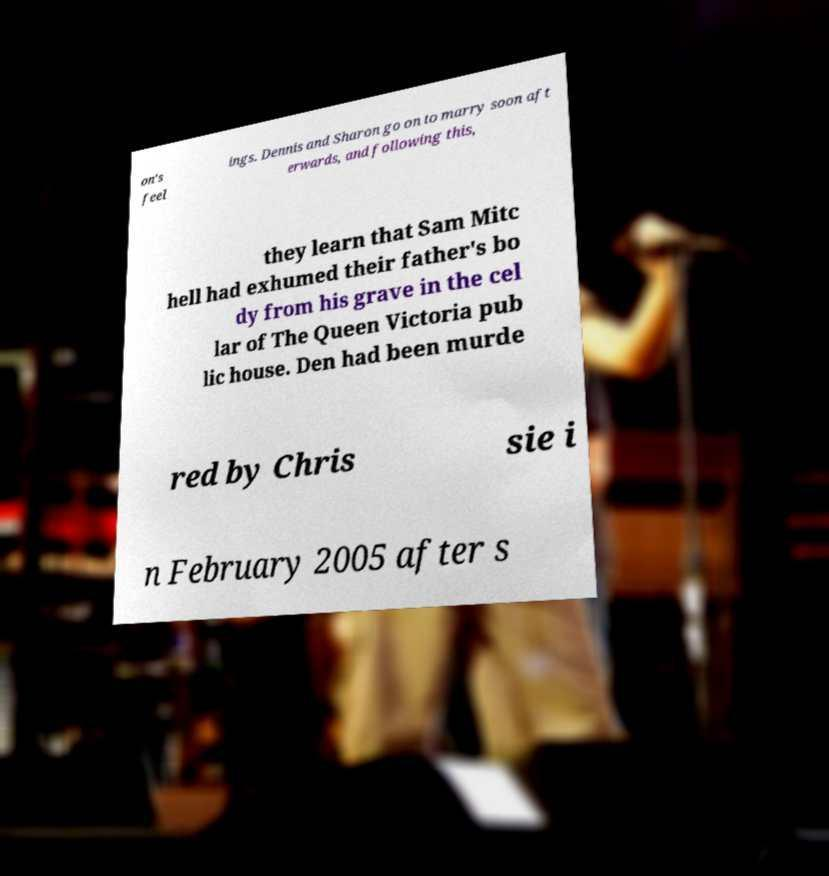Could you assist in decoding the text presented in this image and type it out clearly? on's feel ings. Dennis and Sharon go on to marry soon aft erwards, and following this, they learn that Sam Mitc hell had exhumed their father's bo dy from his grave in the cel lar of The Queen Victoria pub lic house. Den had been murde red by Chris sie i n February 2005 after s 